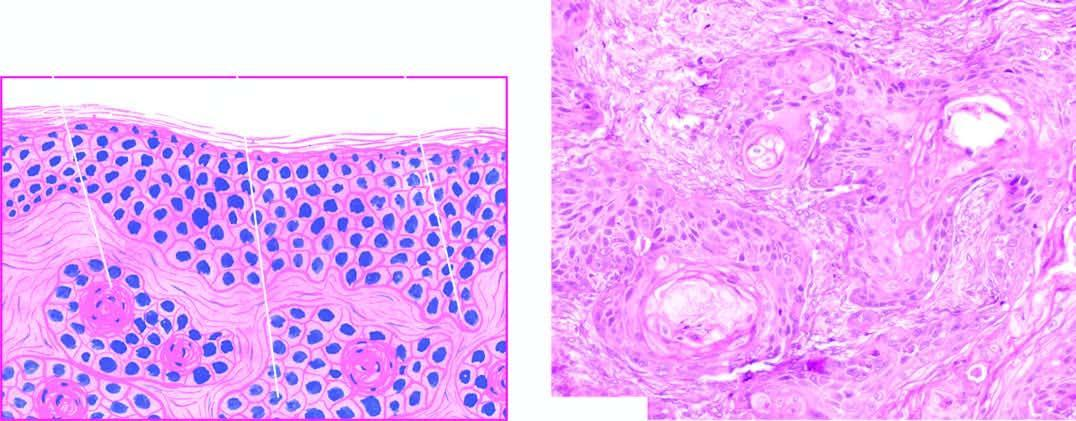s there inflammatory reaction in the dermis between the masses of tumour cells?
Answer the question using a single word or phrase. Yes 